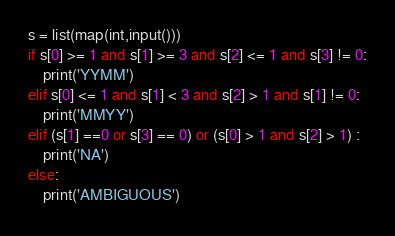<code> <loc_0><loc_0><loc_500><loc_500><_Python_>s = list(map(int,input()))
if s[0] >= 1 and s[1] >= 3 and s[2] <= 1 and s[3] != 0:
    print('YYMM')
elif s[0] <= 1 and s[1] < 3 and s[2] > 1 and s[1] != 0:
    print('MMYY')
elif (s[1] ==0 or s[3] == 0) or (s[0] > 1 and s[2] > 1) :
    print('NA')
else:
    print('AMBIGUOUS')</code> 